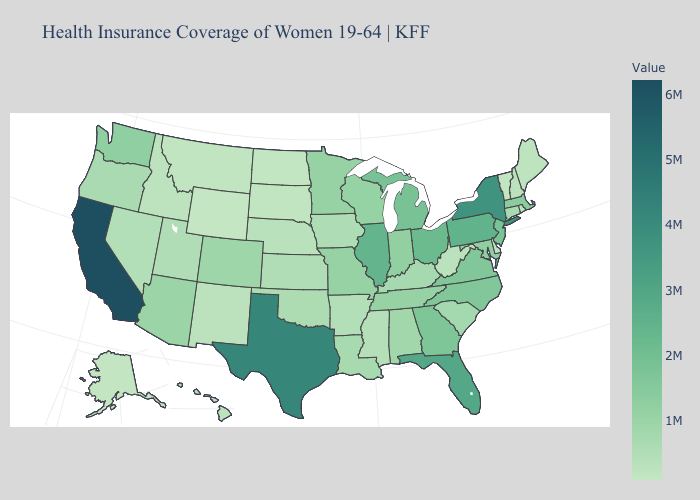Does Utah have the lowest value in the USA?
Answer briefly. No. Among the states that border Pennsylvania , which have the lowest value?
Give a very brief answer. Delaware. Does Arkansas have the lowest value in the USA?
Concise answer only. No. Does Louisiana have a lower value than New Jersey?
Give a very brief answer. Yes. Is the legend a continuous bar?
Answer briefly. Yes. 